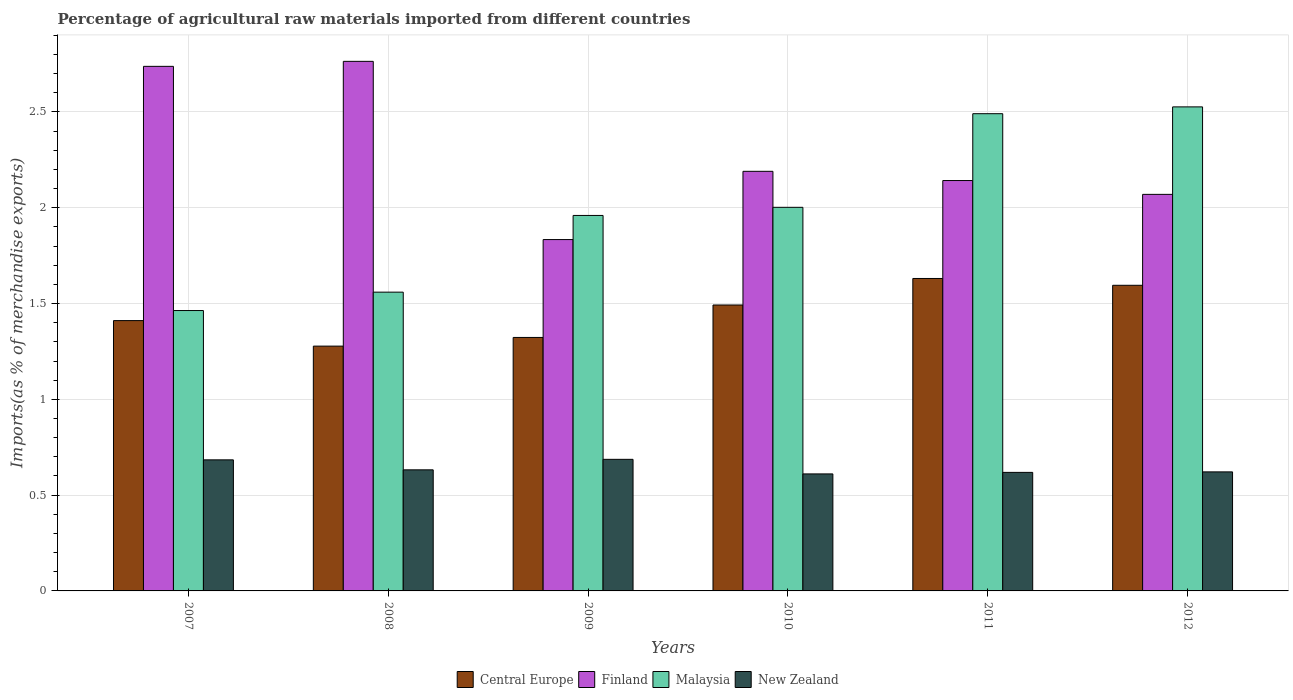How many different coloured bars are there?
Your answer should be very brief. 4. How many groups of bars are there?
Your answer should be very brief. 6. Are the number of bars on each tick of the X-axis equal?
Your response must be concise. Yes. How many bars are there on the 2nd tick from the left?
Provide a succinct answer. 4. How many bars are there on the 6th tick from the right?
Your answer should be very brief. 4. What is the percentage of imports to different countries in New Zealand in 2010?
Provide a succinct answer. 0.61. Across all years, what is the maximum percentage of imports to different countries in New Zealand?
Provide a succinct answer. 0.69. Across all years, what is the minimum percentage of imports to different countries in Central Europe?
Give a very brief answer. 1.28. What is the total percentage of imports to different countries in Finland in the graph?
Make the answer very short. 13.74. What is the difference between the percentage of imports to different countries in New Zealand in 2007 and that in 2008?
Give a very brief answer. 0.05. What is the difference between the percentage of imports to different countries in Finland in 2011 and the percentage of imports to different countries in Malaysia in 2007?
Provide a succinct answer. 0.68. What is the average percentage of imports to different countries in Central Europe per year?
Provide a succinct answer. 1.45. In the year 2012, what is the difference between the percentage of imports to different countries in Central Europe and percentage of imports to different countries in Finland?
Your answer should be compact. -0.47. In how many years, is the percentage of imports to different countries in Central Europe greater than 0.9 %?
Provide a succinct answer. 6. What is the ratio of the percentage of imports to different countries in Central Europe in 2011 to that in 2012?
Offer a terse response. 1.02. Is the difference between the percentage of imports to different countries in Central Europe in 2007 and 2009 greater than the difference between the percentage of imports to different countries in Finland in 2007 and 2009?
Ensure brevity in your answer.  No. What is the difference between the highest and the second highest percentage of imports to different countries in New Zealand?
Your response must be concise. 0. What is the difference between the highest and the lowest percentage of imports to different countries in Malaysia?
Your response must be concise. 1.06. What does the 3rd bar from the left in 2012 represents?
Offer a terse response. Malaysia. What does the 1st bar from the right in 2007 represents?
Ensure brevity in your answer.  New Zealand. Is it the case that in every year, the sum of the percentage of imports to different countries in Finland and percentage of imports to different countries in Malaysia is greater than the percentage of imports to different countries in New Zealand?
Give a very brief answer. Yes. How many bars are there?
Provide a succinct answer. 24. Are all the bars in the graph horizontal?
Ensure brevity in your answer.  No. How many years are there in the graph?
Offer a terse response. 6. Does the graph contain any zero values?
Your answer should be very brief. No. Does the graph contain grids?
Offer a very short reply. Yes. Where does the legend appear in the graph?
Give a very brief answer. Bottom center. What is the title of the graph?
Your answer should be very brief. Percentage of agricultural raw materials imported from different countries. What is the label or title of the X-axis?
Provide a succinct answer. Years. What is the label or title of the Y-axis?
Offer a very short reply. Imports(as % of merchandise exports). What is the Imports(as % of merchandise exports) of Central Europe in 2007?
Offer a terse response. 1.41. What is the Imports(as % of merchandise exports) in Finland in 2007?
Your response must be concise. 2.74. What is the Imports(as % of merchandise exports) in Malaysia in 2007?
Your answer should be compact. 1.46. What is the Imports(as % of merchandise exports) of New Zealand in 2007?
Ensure brevity in your answer.  0.68. What is the Imports(as % of merchandise exports) of Central Europe in 2008?
Give a very brief answer. 1.28. What is the Imports(as % of merchandise exports) of Finland in 2008?
Make the answer very short. 2.76. What is the Imports(as % of merchandise exports) in Malaysia in 2008?
Give a very brief answer. 1.56. What is the Imports(as % of merchandise exports) of New Zealand in 2008?
Your answer should be compact. 0.63. What is the Imports(as % of merchandise exports) of Central Europe in 2009?
Your response must be concise. 1.32. What is the Imports(as % of merchandise exports) of Finland in 2009?
Offer a very short reply. 1.83. What is the Imports(as % of merchandise exports) in Malaysia in 2009?
Keep it short and to the point. 1.96. What is the Imports(as % of merchandise exports) of New Zealand in 2009?
Keep it short and to the point. 0.69. What is the Imports(as % of merchandise exports) of Central Europe in 2010?
Your answer should be very brief. 1.49. What is the Imports(as % of merchandise exports) in Finland in 2010?
Make the answer very short. 2.19. What is the Imports(as % of merchandise exports) of Malaysia in 2010?
Give a very brief answer. 2. What is the Imports(as % of merchandise exports) in New Zealand in 2010?
Keep it short and to the point. 0.61. What is the Imports(as % of merchandise exports) in Central Europe in 2011?
Offer a terse response. 1.63. What is the Imports(as % of merchandise exports) in Finland in 2011?
Offer a terse response. 2.14. What is the Imports(as % of merchandise exports) of Malaysia in 2011?
Your response must be concise. 2.49. What is the Imports(as % of merchandise exports) in New Zealand in 2011?
Your answer should be very brief. 0.62. What is the Imports(as % of merchandise exports) in Central Europe in 2012?
Provide a short and direct response. 1.6. What is the Imports(as % of merchandise exports) in Finland in 2012?
Your answer should be compact. 2.07. What is the Imports(as % of merchandise exports) in Malaysia in 2012?
Your answer should be compact. 2.53. What is the Imports(as % of merchandise exports) of New Zealand in 2012?
Provide a succinct answer. 0.62. Across all years, what is the maximum Imports(as % of merchandise exports) of Central Europe?
Give a very brief answer. 1.63. Across all years, what is the maximum Imports(as % of merchandise exports) of Finland?
Your answer should be very brief. 2.76. Across all years, what is the maximum Imports(as % of merchandise exports) in Malaysia?
Give a very brief answer. 2.53. Across all years, what is the maximum Imports(as % of merchandise exports) of New Zealand?
Offer a very short reply. 0.69. Across all years, what is the minimum Imports(as % of merchandise exports) in Central Europe?
Your answer should be compact. 1.28. Across all years, what is the minimum Imports(as % of merchandise exports) in Finland?
Give a very brief answer. 1.83. Across all years, what is the minimum Imports(as % of merchandise exports) of Malaysia?
Provide a succinct answer. 1.46. Across all years, what is the minimum Imports(as % of merchandise exports) in New Zealand?
Offer a terse response. 0.61. What is the total Imports(as % of merchandise exports) in Central Europe in the graph?
Your answer should be very brief. 8.73. What is the total Imports(as % of merchandise exports) in Finland in the graph?
Your answer should be very brief. 13.74. What is the total Imports(as % of merchandise exports) in Malaysia in the graph?
Ensure brevity in your answer.  12. What is the total Imports(as % of merchandise exports) of New Zealand in the graph?
Make the answer very short. 3.85. What is the difference between the Imports(as % of merchandise exports) in Central Europe in 2007 and that in 2008?
Offer a very short reply. 0.13. What is the difference between the Imports(as % of merchandise exports) in Finland in 2007 and that in 2008?
Provide a succinct answer. -0.03. What is the difference between the Imports(as % of merchandise exports) of Malaysia in 2007 and that in 2008?
Give a very brief answer. -0.1. What is the difference between the Imports(as % of merchandise exports) of New Zealand in 2007 and that in 2008?
Provide a short and direct response. 0.05. What is the difference between the Imports(as % of merchandise exports) in Central Europe in 2007 and that in 2009?
Your response must be concise. 0.09. What is the difference between the Imports(as % of merchandise exports) in Finland in 2007 and that in 2009?
Ensure brevity in your answer.  0.9. What is the difference between the Imports(as % of merchandise exports) of Malaysia in 2007 and that in 2009?
Offer a terse response. -0.5. What is the difference between the Imports(as % of merchandise exports) in New Zealand in 2007 and that in 2009?
Your answer should be compact. -0. What is the difference between the Imports(as % of merchandise exports) in Central Europe in 2007 and that in 2010?
Ensure brevity in your answer.  -0.08. What is the difference between the Imports(as % of merchandise exports) of Finland in 2007 and that in 2010?
Provide a short and direct response. 0.55. What is the difference between the Imports(as % of merchandise exports) in Malaysia in 2007 and that in 2010?
Provide a succinct answer. -0.54. What is the difference between the Imports(as % of merchandise exports) in New Zealand in 2007 and that in 2010?
Keep it short and to the point. 0.07. What is the difference between the Imports(as % of merchandise exports) in Central Europe in 2007 and that in 2011?
Your answer should be compact. -0.22. What is the difference between the Imports(as % of merchandise exports) in Finland in 2007 and that in 2011?
Provide a succinct answer. 0.6. What is the difference between the Imports(as % of merchandise exports) in Malaysia in 2007 and that in 2011?
Your answer should be compact. -1.03. What is the difference between the Imports(as % of merchandise exports) of New Zealand in 2007 and that in 2011?
Provide a short and direct response. 0.07. What is the difference between the Imports(as % of merchandise exports) in Central Europe in 2007 and that in 2012?
Ensure brevity in your answer.  -0.18. What is the difference between the Imports(as % of merchandise exports) of Finland in 2007 and that in 2012?
Ensure brevity in your answer.  0.67. What is the difference between the Imports(as % of merchandise exports) of Malaysia in 2007 and that in 2012?
Give a very brief answer. -1.06. What is the difference between the Imports(as % of merchandise exports) in New Zealand in 2007 and that in 2012?
Your answer should be very brief. 0.06. What is the difference between the Imports(as % of merchandise exports) in Central Europe in 2008 and that in 2009?
Make the answer very short. -0.05. What is the difference between the Imports(as % of merchandise exports) in Finland in 2008 and that in 2009?
Make the answer very short. 0.93. What is the difference between the Imports(as % of merchandise exports) of Malaysia in 2008 and that in 2009?
Make the answer very short. -0.4. What is the difference between the Imports(as % of merchandise exports) of New Zealand in 2008 and that in 2009?
Make the answer very short. -0.05. What is the difference between the Imports(as % of merchandise exports) of Central Europe in 2008 and that in 2010?
Make the answer very short. -0.21. What is the difference between the Imports(as % of merchandise exports) in Finland in 2008 and that in 2010?
Offer a terse response. 0.57. What is the difference between the Imports(as % of merchandise exports) in Malaysia in 2008 and that in 2010?
Ensure brevity in your answer.  -0.44. What is the difference between the Imports(as % of merchandise exports) of New Zealand in 2008 and that in 2010?
Offer a terse response. 0.02. What is the difference between the Imports(as % of merchandise exports) of Central Europe in 2008 and that in 2011?
Your response must be concise. -0.35. What is the difference between the Imports(as % of merchandise exports) of Finland in 2008 and that in 2011?
Ensure brevity in your answer.  0.62. What is the difference between the Imports(as % of merchandise exports) in Malaysia in 2008 and that in 2011?
Your answer should be very brief. -0.93. What is the difference between the Imports(as % of merchandise exports) in New Zealand in 2008 and that in 2011?
Keep it short and to the point. 0.01. What is the difference between the Imports(as % of merchandise exports) in Central Europe in 2008 and that in 2012?
Offer a terse response. -0.32. What is the difference between the Imports(as % of merchandise exports) of Finland in 2008 and that in 2012?
Keep it short and to the point. 0.69. What is the difference between the Imports(as % of merchandise exports) of Malaysia in 2008 and that in 2012?
Keep it short and to the point. -0.97. What is the difference between the Imports(as % of merchandise exports) in New Zealand in 2008 and that in 2012?
Keep it short and to the point. 0.01. What is the difference between the Imports(as % of merchandise exports) in Central Europe in 2009 and that in 2010?
Keep it short and to the point. -0.17. What is the difference between the Imports(as % of merchandise exports) of Finland in 2009 and that in 2010?
Provide a succinct answer. -0.36. What is the difference between the Imports(as % of merchandise exports) in Malaysia in 2009 and that in 2010?
Make the answer very short. -0.04. What is the difference between the Imports(as % of merchandise exports) of New Zealand in 2009 and that in 2010?
Provide a succinct answer. 0.08. What is the difference between the Imports(as % of merchandise exports) of Central Europe in 2009 and that in 2011?
Your response must be concise. -0.31. What is the difference between the Imports(as % of merchandise exports) in Finland in 2009 and that in 2011?
Offer a terse response. -0.31. What is the difference between the Imports(as % of merchandise exports) in Malaysia in 2009 and that in 2011?
Give a very brief answer. -0.53. What is the difference between the Imports(as % of merchandise exports) in New Zealand in 2009 and that in 2011?
Provide a succinct answer. 0.07. What is the difference between the Imports(as % of merchandise exports) of Central Europe in 2009 and that in 2012?
Make the answer very short. -0.27. What is the difference between the Imports(as % of merchandise exports) of Finland in 2009 and that in 2012?
Offer a very short reply. -0.24. What is the difference between the Imports(as % of merchandise exports) of Malaysia in 2009 and that in 2012?
Ensure brevity in your answer.  -0.57. What is the difference between the Imports(as % of merchandise exports) in New Zealand in 2009 and that in 2012?
Provide a succinct answer. 0.07. What is the difference between the Imports(as % of merchandise exports) in Central Europe in 2010 and that in 2011?
Make the answer very short. -0.14. What is the difference between the Imports(as % of merchandise exports) of Finland in 2010 and that in 2011?
Ensure brevity in your answer.  0.05. What is the difference between the Imports(as % of merchandise exports) in Malaysia in 2010 and that in 2011?
Your response must be concise. -0.49. What is the difference between the Imports(as % of merchandise exports) of New Zealand in 2010 and that in 2011?
Offer a very short reply. -0.01. What is the difference between the Imports(as % of merchandise exports) in Central Europe in 2010 and that in 2012?
Provide a short and direct response. -0.1. What is the difference between the Imports(as % of merchandise exports) in Finland in 2010 and that in 2012?
Your response must be concise. 0.12. What is the difference between the Imports(as % of merchandise exports) in Malaysia in 2010 and that in 2012?
Your answer should be compact. -0.52. What is the difference between the Imports(as % of merchandise exports) of New Zealand in 2010 and that in 2012?
Your response must be concise. -0.01. What is the difference between the Imports(as % of merchandise exports) in Central Europe in 2011 and that in 2012?
Provide a short and direct response. 0.04. What is the difference between the Imports(as % of merchandise exports) of Finland in 2011 and that in 2012?
Keep it short and to the point. 0.07. What is the difference between the Imports(as % of merchandise exports) in Malaysia in 2011 and that in 2012?
Provide a succinct answer. -0.04. What is the difference between the Imports(as % of merchandise exports) of New Zealand in 2011 and that in 2012?
Give a very brief answer. -0. What is the difference between the Imports(as % of merchandise exports) in Central Europe in 2007 and the Imports(as % of merchandise exports) in Finland in 2008?
Provide a short and direct response. -1.35. What is the difference between the Imports(as % of merchandise exports) in Central Europe in 2007 and the Imports(as % of merchandise exports) in Malaysia in 2008?
Offer a very short reply. -0.15. What is the difference between the Imports(as % of merchandise exports) in Central Europe in 2007 and the Imports(as % of merchandise exports) in New Zealand in 2008?
Provide a short and direct response. 0.78. What is the difference between the Imports(as % of merchandise exports) of Finland in 2007 and the Imports(as % of merchandise exports) of Malaysia in 2008?
Your response must be concise. 1.18. What is the difference between the Imports(as % of merchandise exports) of Finland in 2007 and the Imports(as % of merchandise exports) of New Zealand in 2008?
Provide a succinct answer. 2.11. What is the difference between the Imports(as % of merchandise exports) in Malaysia in 2007 and the Imports(as % of merchandise exports) in New Zealand in 2008?
Your answer should be compact. 0.83. What is the difference between the Imports(as % of merchandise exports) in Central Europe in 2007 and the Imports(as % of merchandise exports) in Finland in 2009?
Keep it short and to the point. -0.42. What is the difference between the Imports(as % of merchandise exports) of Central Europe in 2007 and the Imports(as % of merchandise exports) of Malaysia in 2009?
Offer a terse response. -0.55. What is the difference between the Imports(as % of merchandise exports) in Central Europe in 2007 and the Imports(as % of merchandise exports) in New Zealand in 2009?
Provide a succinct answer. 0.72. What is the difference between the Imports(as % of merchandise exports) in Finland in 2007 and the Imports(as % of merchandise exports) in Malaysia in 2009?
Your response must be concise. 0.78. What is the difference between the Imports(as % of merchandise exports) of Finland in 2007 and the Imports(as % of merchandise exports) of New Zealand in 2009?
Your response must be concise. 2.05. What is the difference between the Imports(as % of merchandise exports) in Malaysia in 2007 and the Imports(as % of merchandise exports) in New Zealand in 2009?
Give a very brief answer. 0.78. What is the difference between the Imports(as % of merchandise exports) in Central Europe in 2007 and the Imports(as % of merchandise exports) in Finland in 2010?
Keep it short and to the point. -0.78. What is the difference between the Imports(as % of merchandise exports) in Central Europe in 2007 and the Imports(as % of merchandise exports) in Malaysia in 2010?
Your answer should be compact. -0.59. What is the difference between the Imports(as % of merchandise exports) of Central Europe in 2007 and the Imports(as % of merchandise exports) of New Zealand in 2010?
Offer a terse response. 0.8. What is the difference between the Imports(as % of merchandise exports) in Finland in 2007 and the Imports(as % of merchandise exports) in Malaysia in 2010?
Offer a very short reply. 0.74. What is the difference between the Imports(as % of merchandise exports) in Finland in 2007 and the Imports(as % of merchandise exports) in New Zealand in 2010?
Your answer should be very brief. 2.13. What is the difference between the Imports(as % of merchandise exports) in Malaysia in 2007 and the Imports(as % of merchandise exports) in New Zealand in 2010?
Keep it short and to the point. 0.85. What is the difference between the Imports(as % of merchandise exports) of Central Europe in 2007 and the Imports(as % of merchandise exports) of Finland in 2011?
Give a very brief answer. -0.73. What is the difference between the Imports(as % of merchandise exports) in Central Europe in 2007 and the Imports(as % of merchandise exports) in Malaysia in 2011?
Give a very brief answer. -1.08. What is the difference between the Imports(as % of merchandise exports) of Central Europe in 2007 and the Imports(as % of merchandise exports) of New Zealand in 2011?
Your answer should be compact. 0.79. What is the difference between the Imports(as % of merchandise exports) in Finland in 2007 and the Imports(as % of merchandise exports) in Malaysia in 2011?
Your response must be concise. 0.25. What is the difference between the Imports(as % of merchandise exports) of Finland in 2007 and the Imports(as % of merchandise exports) of New Zealand in 2011?
Your response must be concise. 2.12. What is the difference between the Imports(as % of merchandise exports) of Malaysia in 2007 and the Imports(as % of merchandise exports) of New Zealand in 2011?
Your answer should be very brief. 0.84. What is the difference between the Imports(as % of merchandise exports) of Central Europe in 2007 and the Imports(as % of merchandise exports) of Finland in 2012?
Offer a terse response. -0.66. What is the difference between the Imports(as % of merchandise exports) in Central Europe in 2007 and the Imports(as % of merchandise exports) in Malaysia in 2012?
Your answer should be compact. -1.12. What is the difference between the Imports(as % of merchandise exports) of Central Europe in 2007 and the Imports(as % of merchandise exports) of New Zealand in 2012?
Your response must be concise. 0.79. What is the difference between the Imports(as % of merchandise exports) in Finland in 2007 and the Imports(as % of merchandise exports) in Malaysia in 2012?
Give a very brief answer. 0.21. What is the difference between the Imports(as % of merchandise exports) of Finland in 2007 and the Imports(as % of merchandise exports) of New Zealand in 2012?
Keep it short and to the point. 2.12. What is the difference between the Imports(as % of merchandise exports) in Malaysia in 2007 and the Imports(as % of merchandise exports) in New Zealand in 2012?
Offer a terse response. 0.84. What is the difference between the Imports(as % of merchandise exports) in Central Europe in 2008 and the Imports(as % of merchandise exports) in Finland in 2009?
Your answer should be very brief. -0.56. What is the difference between the Imports(as % of merchandise exports) of Central Europe in 2008 and the Imports(as % of merchandise exports) of Malaysia in 2009?
Keep it short and to the point. -0.68. What is the difference between the Imports(as % of merchandise exports) in Central Europe in 2008 and the Imports(as % of merchandise exports) in New Zealand in 2009?
Provide a succinct answer. 0.59. What is the difference between the Imports(as % of merchandise exports) in Finland in 2008 and the Imports(as % of merchandise exports) in Malaysia in 2009?
Keep it short and to the point. 0.8. What is the difference between the Imports(as % of merchandise exports) of Finland in 2008 and the Imports(as % of merchandise exports) of New Zealand in 2009?
Offer a terse response. 2.08. What is the difference between the Imports(as % of merchandise exports) in Malaysia in 2008 and the Imports(as % of merchandise exports) in New Zealand in 2009?
Give a very brief answer. 0.87. What is the difference between the Imports(as % of merchandise exports) in Central Europe in 2008 and the Imports(as % of merchandise exports) in Finland in 2010?
Ensure brevity in your answer.  -0.91. What is the difference between the Imports(as % of merchandise exports) in Central Europe in 2008 and the Imports(as % of merchandise exports) in Malaysia in 2010?
Your answer should be very brief. -0.72. What is the difference between the Imports(as % of merchandise exports) in Central Europe in 2008 and the Imports(as % of merchandise exports) in New Zealand in 2010?
Offer a terse response. 0.67. What is the difference between the Imports(as % of merchandise exports) of Finland in 2008 and the Imports(as % of merchandise exports) of Malaysia in 2010?
Your answer should be compact. 0.76. What is the difference between the Imports(as % of merchandise exports) in Finland in 2008 and the Imports(as % of merchandise exports) in New Zealand in 2010?
Offer a very short reply. 2.15. What is the difference between the Imports(as % of merchandise exports) of Malaysia in 2008 and the Imports(as % of merchandise exports) of New Zealand in 2010?
Ensure brevity in your answer.  0.95. What is the difference between the Imports(as % of merchandise exports) in Central Europe in 2008 and the Imports(as % of merchandise exports) in Finland in 2011?
Offer a very short reply. -0.86. What is the difference between the Imports(as % of merchandise exports) of Central Europe in 2008 and the Imports(as % of merchandise exports) of Malaysia in 2011?
Offer a terse response. -1.21. What is the difference between the Imports(as % of merchandise exports) in Central Europe in 2008 and the Imports(as % of merchandise exports) in New Zealand in 2011?
Ensure brevity in your answer.  0.66. What is the difference between the Imports(as % of merchandise exports) of Finland in 2008 and the Imports(as % of merchandise exports) of Malaysia in 2011?
Give a very brief answer. 0.27. What is the difference between the Imports(as % of merchandise exports) of Finland in 2008 and the Imports(as % of merchandise exports) of New Zealand in 2011?
Keep it short and to the point. 2.15. What is the difference between the Imports(as % of merchandise exports) in Malaysia in 2008 and the Imports(as % of merchandise exports) in New Zealand in 2011?
Your answer should be compact. 0.94. What is the difference between the Imports(as % of merchandise exports) in Central Europe in 2008 and the Imports(as % of merchandise exports) in Finland in 2012?
Provide a succinct answer. -0.79. What is the difference between the Imports(as % of merchandise exports) in Central Europe in 2008 and the Imports(as % of merchandise exports) in Malaysia in 2012?
Keep it short and to the point. -1.25. What is the difference between the Imports(as % of merchandise exports) of Central Europe in 2008 and the Imports(as % of merchandise exports) of New Zealand in 2012?
Keep it short and to the point. 0.66. What is the difference between the Imports(as % of merchandise exports) in Finland in 2008 and the Imports(as % of merchandise exports) in Malaysia in 2012?
Offer a terse response. 0.24. What is the difference between the Imports(as % of merchandise exports) in Finland in 2008 and the Imports(as % of merchandise exports) in New Zealand in 2012?
Keep it short and to the point. 2.14. What is the difference between the Imports(as % of merchandise exports) in Malaysia in 2008 and the Imports(as % of merchandise exports) in New Zealand in 2012?
Your answer should be compact. 0.94. What is the difference between the Imports(as % of merchandise exports) in Central Europe in 2009 and the Imports(as % of merchandise exports) in Finland in 2010?
Ensure brevity in your answer.  -0.87. What is the difference between the Imports(as % of merchandise exports) in Central Europe in 2009 and the Imports(as % of merchandise exports) in Malaysia in 2010?
Your answer should be very brief. -0.68. What is the difference between the Imports(as % of merchandise exports) of Central Europe in 2009 and the Imports(as % of merchandise exports) of New Zealand in 2010?
Your answer should be compact. 0.71. What is the difference between the Imports(as % of merchandise exports) in Finland in 2009 and the Imports(as % of merchandise exports) in Malaysia in 2010?
Make the answer very short. -0.17. What is the difference between the Imports(as % of merchandise exports) of Finland in 2009 and the Imports(as % of merchandise exports) of New Zealand in 2010?
Ensure brevity in your answer.  1.22. What is the difference between the Imports(as % of merchandise exports) of Malaysia in 2009 and the Imports(as % of merchandise exports) of New Zealand in 2010?
Ensure brevity in your answer.  1.35. What is the difference between the Imports(as % of merchandise exports) of Central Europe in 2009 and the Imports(as % of merchandise exports) of Finland in 2011?
Offer a terse response. -0.82. What is the difference between the Imports(as % of merchandise exports) in Central Europe in 2009 and the Imports(as % of merchandise exports) in Malaysia in 2011?
Make the answer very short. -1.17. What is the difference between the Imports(as % of merchandise exports) in Central Europe in 2009 and the Imports(as % of merchandise exports) in New Zealand in 2011?
Keep it short and to the point. 0.7. What is the difference between the Imports(as % of merchandise exports) of Finland in 2009 and the Imports(as % of merchandise exports) of Malaysia in 2011?
Provide a succinct answer. -0.66. What is the difference between the Imports(as % of merchandise exports) of Finland in 2009 and the Imports(as % of merchandise exports) of New Zealand in 2011?
Your response must be concise. 1.22. What is the difference between the Imports(as % of merchandise exports) of Malaysia in 2009 and the Imports(as % of merchandise exports) of New Zealand in 2011?
Your response must be concise. 1.34. What is the difference between the Imports(as % of merchandise exports) in Central Europe in 2009 and the Imports(as % of merchandise exports) in Finland in 2012?
Offer a terse response. -0.75. What is the difference between the Imports(as % of merchandise exports) in Central Europe in 2009 and the Imports(as % of merchandise exports) in Malaysia in 2012?
Your answer should be very brief. -1.2. What is the difference between the Imports(as % of merchandise exports) in Central Europe in 2009 and the Imports(as % of merchandise exports) in New Zealand in 2012?
Offer a very short reply. 0.7. What is the difference between the Imports(as % of merchandise exports) of Finland in 2009 and the Imports(as % of merchandise exports) of Malaysia in 2012?
Your response must be concise. -0.69. What is the difference between the Imports(as % of merchandise exports) in Finland in 2009 and the Imports(as % of merchandise exports) in New Zealand in 2012?
Your response must be concise. 1.21. What is the difference between the Imports(as % of merchandise exports) of Malaysia in 2009 and the Imports(as % of merchandise exports) of New Zealand in 2012?
Provide a succinct answer. 1.34. What is the difference between the Imports(as % of merchandise exports) in Central Europe in 2010 and the Imports(as % of merchandise exports) in Finland in 2011?
Your answer should be compact. -0.65. What is the difference between the Imports(as % of merchandise exports) in Central Europe in 2010 and the Imports(as % of merchandise exports) in Malaysia in 2011?
Your answer should be compact. -1. What is the difference between the Imports(as % of merchandise exports) in Central Europe in 2010 and the Imports(as % of merchandise exports) in New Zealand in 2011?
Keep it short and to the point. 0.87. What is the difference between the Imports(as % of merchandise exports) in Finland in 2010 and the Imports(as % of merchandise exports) in Malaysia in 2011?
Your response must be concise. -0.3. What is the difference between the Imports(as % of merchandise exports) in Finland in 2010 and the Imports(as % of merchandise exports) in New Zealand in 2011?
Ensure brevity in your answer.  1.57. What is the difference between the Imports(as % of merchandise exports) in Malaysia in 2010 and the Imports(as % of merchandise exports) in New Zealand in 2011?
Keep it short and to the point. 1.38. What is the difference between the Imports(as % of merchandise exports) of Central Europe in 2010 and the Imports(as % of merchandise exports) of Finland in 2012?
Provide a short and direct response. -0.58. What is the difference between the Imports(as % of merchandise exports) of Central Europe in 2010 and the Imports(as % of merchandise exports) of Malaysia in 2012?
Your answer should be very brief. -1.03. What is the difference between the Imports(as % of merchandise exports) in Central Europe in 2010 and the Imports(as % of merchandise exports) in New Zealand in 2012?
Keep it short and to the point. 0.87. What is the difference between the Imports(as % of merchandise exports) in Finland in 2010 and the Imports(as % of merchandise exports) in Malaysia in 2012?
Keep it short and to the point. -0.34. What is the difference between the Imports(as % of merchandise exports) in Finland in 2010 and the Imports(as % of merchandise exports) in New Zealand in 2012?
Keep it short and to the point. 1.57. What is the difference between the Imports(as % of merchandise exports) of Malaysia in 2010 and the Imports(as % of merchandise exports) of New Zealand in 2012?
Make the answer very short. 1.38. What is the difference between the Imports(as % of merchandise exports) in Central Europe in 2011 and the Imports(as % of merchandise exports) in Finland in 2012?
Ensure brevity in your answer.  -0.44. What is the difference between the Imports(as % of merchandise exports) in Central Europe in 2011 and the Imports(as % of merchandise exports) in Malaysia in 2012?
Make the answer very short. -0.9. What is the difference between the Imports(as % of merchandise exports) in Central Europe in 2011 and the Imports(as % of merchandise exports) in New Zealand in 2012?
Provide a short and direct response. 1.01. What is the difference between the Imports(as % of merchandise exports) in Finland in 2011 and the Imports(as % of merchandise exports) in Malaysia in 2012?
Your answer should be very brief. -0.38. What is the difference between the Imports(as % of merchandise exports) of Finland in 2011 and the Imports(as % of merchandise exports) of New Zealand in 2012?
Offer a very short reply. 1.52. What is the difference between the Imports(as % of merchandise exports) of Malaysia in 2011 and the Imports(as % of merchandise exports) of New Zealand in 2012?
Ensure brevity in your answer.  1.87. What is the average Imports(as % of merchandise exports) of Central Europe per year?
Your answer should be very brief. 1.45. What is the average Imports(as % of merchandise exports) in Finland per year?
Ensure brevity in your answer.  2.29. What is the average Imports(as % of merchandise exports) in Malaysia per year?
Keep it short and to the point. 2. What is the average Imports(as % of merchandise exports) of New Zealand per year?
Offer a very short reply. 0.64. In the year 2007, what is the difference between the Imports(as % of merchandise exports) of Central Europe and Imports(as % of merchandise exports) of Finland?
Offer a very short reply. -1.33. In the year 2007, what is the difference between the Imports(as % of merchandise exports) of Central Europe and Imports(as % of merchandise exports) of Malaysia?
Provide a succinct answer. -0.05. In the year 2007, what is the difference between the Imports(as % of merchandise exports) of Central Europe and Imports(as % of merchandise exports) of New Zealand?
Your response must be concise. 0.73. In the year 2007, what is the difference between the Imports(as % of merchandise exports) in Finland and Imports(as % of merchandise exports) in Malaysia?
Your response must be concise. 1.27. In the year 2007, what is the difference between the Imports(as % of merchandise exports) of Finland and Imports(as % of merchandise exports) of New Zealand?
Ensure brevity in your answer.  2.05. In the year 2007, what is the difference between the Imports(as % of merchandise exports) in Malaysia and Imports(as % of merchandise exports) in New Zealand?
Your response must be concise. 0.78. In the year 2008, what is the difference between the Imports(as % of merchandise exports) of Central Europe and Imports(as % of merchandise exports) of Finland?
Keep it short and to the point. -1.49. In the year 2008, what is the difference between the Imports(as % of merchandise exports) of Central Europe and Imports(as % of merchandise exports) of Malaysia?
Your answer should be very brief. -0.28. In the year 2008, what is the difference between the Imports(as % of merchandise exports) in Central Europe and Imports(as % of merchandise exports) in New Zealand?
Give a very brief answer. 0.65. In the year 2008, what is the difference between the Imports(as % of merchandise exports) of Finland and Imports(as % of merchandise exports) of Malaysia?
Offer a very short reply. 1.2. In the year 2008, what is the difference between the Imports(as % of merchandise exports) of Finland and Imports(as % of merchandise exports) of New Zealand?
Provide a succinct answer. 2.13. In the year 2008, what is the difference between the Imports(as % of merchandise exports) in Malaysia and Imports(as % of merchandise exports) in New Zealand?
Give a very brief answer. 0.93. In the year 2009, what is the difference between the Imports(as % of merchandise exports) of Central Europe and Imports(as % of merchandise exports) of Finland?
Offer a terse response. -0.51. In the year 2009, what is the difference between the Imports(as % of merchandise exports) in Central Europe and Imports(as % of merchandise exports) in Malaysia?
Your response must be concise. -0.64. In the year 2009, what is the difference between the Imports(as % of merchandise exports) of Central Europe and Imports(as % of merchandise exports) of New Zealand?
Ensure brevity in your answer.  0.64. In the year 2009, what is the difference between the Imports(as % of merchandise exports) in Finland and Imports(as % of merchandise exports) in Malaysia?
Offer a terse response. -0.13. In the year 2009, what is the difference between the Imports(as % of merchandise exports) of Finland and Imports(as % of merchandise exports) of New Zealand?
Offer a terse response. 1.15. In the year 2009, what is the difference between the Imports(as % of merchandise exports) of Malaysia and Imports(as % of merchandise exports) of New Zealand?
Your response must be concise. 1.27. In the year 2010, what is the difference between the Imports(as % of merchandise exports) in Central Europe and Imports(as % of merchandise exports) in Finland?
Your response must be concise. -0.7. In the year 2010, what is the difference between the Imports(as % of merchandise exports) in Central Europe and Imports(as % of merchandise exports) in Malaysia?
Ensure brevity in your answer.  -0.51. In the year 2010, what is the difference between the Imports(as % of merchandise exports) in Central Europe and Imports(as % of merchandise exports) in New Zealand?
Make the answer very short. 0.88. In the year 2010, what is the difference between the Imports(as % of merchandise exports) of Finland and Imports(as % of merchandise exports) of Malaysia?
Keep it short and to the point. 0.19. In the year 2010, what is the difference between the Imports(as % of merchandise exports) of Finland and Imports(as % of merchandise exports) of New Zealand?
Offer a terse response. 1.58. In the year 2010, what is the difference between the Imports(as % of merchandise exports) of Malaysia and Imports(as % of merchandise exports) of New Zealand?
Your response must be concise. 1.39. In the year 2011, what is the difference between the Imports(as % of merchandise exports) of Central Europe and Imports(as % of merchandise exports) of Finland?
Make the answer very short. -0.51. In the year 2011, what is the difference between the Imports(as % of merchandise exports) of Central Europe and Imports(as % of merchandise exports) of Malaysia?
Provide a succinct answer. -0.86. In the year 2011, what is the difference between the Imports(as % of merchandise exports) of Finland and Imports(as % of merchandise exports) of Malaysia?
Offer a very short reply. -0.35. In the year 2011, what is the difference between the Imports(as % of merchandise exports) of Finland and Imports(as % of merchandise exports) of New Zealand?
Your response must be concise. 1.52. In the year 2011, what is the difference between the Imports(as % of merchandise exports) in Malaysia and Imports(as % of merchandise exports) in New Zealand?
Make the answer very short. 1.87. In the year 2012, what is the difference between the Imports(as % of merchandise exports) in Central Europe and Imports(as % of merchandise exports) in Finland?
Your answer should be compact. -0.47. In the year 2012, what is the difference between the Imports(as % of merchandise exports) in Central Europe and Imports(as % of merchandise exports) in Malaysia?
Make the answer very short. -0.93. In the year 2012, what is the difference between the Imports(as % of merchandise exports) in Central Europe and Imports(as % of merchandise exports) in New Zealand?
Give a very brief answer. 0.97. In the year 2012, what is the difference between the Imports(as % of merchandise exports) in Finland and Imports(as % of merchandise exports) in Malaysia?
Make the answer very short. -0.46. In the year 2012, what is the difference between the Imports(as % of merchandise exports) of Finland and Imports(as % of merchandise exports) of New Zealand?
Your answer should be very brief. 1.45. In the year 2012, what is the difference between the Imports(as % of merchandise exports) of Malaysia and Imports(as % of merchandise exports) of New Zealand?
Your answer should be compact. 1.91. What is the ratio of the Imports(as % of merchandise exports) of Central Europe in 2007 to that in 2008?
Provide a succinct answer. 1.1. What is the ratio of the Imports(as % of merchandise exports) of Finland in 2007 to that in 2008?
Your answer should be compact. 0.99. What is the ratio of the Imports(as % of merchandise exports) of Malaysia in 2007 to that in 2008?
Keep it short and to the point. 0.94. What is the ratio of the Imports(as % of merchandise exports) in New Zealand in 2007 to that in 2008?
Provide a short and direct response. 1.08. What is the ratio of the Imports(as % of merchandise exports) of Central Europe in 2007 to that in 2009?
Offer a terse response. 1.07. What is the ratio of the Imports(as % of merchandise exports) in Finland in 2007 to that in 2009?
Your answer should be compact. 1.49. What is the ratio of the Imports(as % of merchandise exports) in Malaysia in 2007 to that in 2009?
Make the answer very short. 0.75. What is the ratio of the Imports(as % of merchandise exports) of New Zealand in 2007 to that in 2009?
Provide a short and direct response. 1. What is the ratio of the Imports(as % of merchandise exports) in Central Europe in 2007 to that in 2010?
Provide a short and direct response. 0.95. What is the ratio of the Imports(as % of merchandise exports) of Finland in 2007 to that in 2010?
Your response must be concise. 1.25. What is the ratio of the Imports(as % of merchandise exports) of Malaysia in 2007 to that in 2010?
Ensure brevity in your answer.  0.73. What is the ratio of the Imports(as % of merchandise exports) of New Zealand in 2007 to that in 2010?
Your response must be concise. 1.12. What is the ratio of the Imports(as % of merchandise exports) in Central Europe in 2007 to that in 2011?
Provide a succinct answer. 0.87. What is the ratio of the Imports(as % of merchandise exports) of Finland in 2007 to that in 2011?
Ensure brevity in your answer.  1.28. What is the ratio of the Imports(as % of merchandise exports) of Malaysia in 2007 to that in 2011?
Offer a terse response. 0.59. What is the ratio of the Imports(as % of merchandise exports) in New Zealand in 2007 to that in 2011?
Give a very brief answer. 1.11. What is the ratio of the Imports(as % of merchandise exports) of Central Europe in 2007 to that in 2012?
Your response must be concise. 0.88. What is the ratio of the Imports(as % of merchandise exports) in Finland in 2007 to that in 2012?
Offer a terse response. 1.32. What is the ratio of the Imports(as % of merchandise exports) in Malaysia in 2007 to that in 2012?
Your response must be concise. 0.58. What is the ratio of the Imports(as % of merchandise exports) in New Zealand in 2007 to that in 2012?
Ensure brevity in your answer.  1.1. What is the ratio of the Imports(as % of merchandise exports) of Central Europe in 2008 to that in 2009?
Make the answer very short. 0.97. What is the ratio of the Imports(as % of merchandise exports) in Finland in 2008 to that in 2009?
Your response must be concise. 1.51. What is the ratio of the Imports(as % of merchandise exports) of Malaysia in 2008 to that in 2009?
Your response must be concise. 0.8. What is the ratio of the Imports(as % of merchandise exports) of New Zealand in 2008 to that in 2009?
Give a very brief answer. 0.92. What is the ratio of the Imports(as % of merchandise exports) in Central Europe in 2008 to that in 2010?
Your answer should be compact. 0.86. What is the ratio of the Imports(as % of merchandise exports) in Finland in 2008 to that in 2010?
Your answer should be very brief. 1.26. What is the ratio of the Imports(as % of merchandise exports) in Malaysia in 2008 to that in 2010?
Provide a succinct answer. 0.78. What is the ratio of the Imports(as % of merchandise exports) in New Zealand in 2008 to that in 2010?
Your answer should be very brief. 1.03. What is the ratio of the Imports(as % of merchandise exports) of Central Europe in 2008 to that in 2011?
Offer a terse response. 0.78. What is the ratio of the Imports(as % of merchandise exports) of Finland in 2008 to that in 2011?
Offer a terse response. 1.29. What is the ratio of the Imports(as % of merchandise exports) of Malaysia in 2008 to that in 2011?
Your answer should be compact. 0.63. What is the ratio of the Imports(as % of merchandise exports) in New Zealand in 2008 to that in 2011?
Keep it short and to the point. 1.02. What is the ratio of the Imports(as % of merchandise exports) in Central Europe in 2008 to that in 2012?
Your response must be concise. 0.8. What is the ratio of the Imports(as % of merchandise exports) of Finland in 2008 to that in 2012?
Make the answer very short. 1.34. What is the ratio of the Imports(as % of merchandise exports) in Malaysia in 2008 to that in 2012?
Your response must be concise. 0.62. What is the ratio of the Imports(as % of merchandise exports) of New Zealand in 2008 to that in 2012?
Offer a very short reply. 1.02. What is the ratio of the Imports(as % of merchandise exports) of Central Europe in 2009 to that in 2010?
Your response must be concise. 0.89. What is the ratio of the Imports(as % of merchandise exports) of Finland in 2009 to that in 2010?
Give a very brief answer. 0.84. What is the ratio of the Imports(as % of merchandise exports) in Malaysia in 2009 to that in 2010?
Ensure brevity in your answer.  0.98. What is the ratio of the Imports(as % of merchandise exports) in New Zealand in 2009 to that in 2010?
Your response must be concise. 1.12. What is the ratio of the Imports(as % of merchandise exports) of Central Europe in 2009 to that in 2011?
Your answer should be very brief. 0.81. What is the ratio of the Imports(as % of merchandise exports) in Finland in 2009 to that in 2011?
Provide a short and direct response. 0.86. What is the ratio of the Imports(as % of merchandise exports) in Malaysia in 2009 to that in 2011?
Keep it short and to the point. 0.79. What is the ratio of the Imports(as % of merchandise exports) in New Zealand in 2009 to that in 2011?
Offer a very short reply. 1.11. What is the ratio of the Imports(as % of merchandise exports) in Central Europe in 2009 to that in 2012?
Provide a short and direct response. 0.83. What is the ratio of the Imports(as % of merchandise exports) of Finland in 2009 to that in 2012?
Offer a terse response. 0.89. What is the ratio of the Imports(as % of merchandise exports) in Malaysia in 2009 to that in 2012?
Make the answer very short. 0.78. What is the ratio of the Imports(as % of merchandise exports) of New Zealand in 2009 to that in 2012?
Your response must be concise. 1.11. What is the ratio of the Imports(as % of merchandise exports) in Central Europe in 2010 to that in 2011?
Your answer should be very brief. 0.92. What is the ratio of the Imports(as % of merchandise exports) of Finland in 2010 to that in 2011?
Your response must be concise. 1.02. What is the ratio of the Imports(as % of merchandise exports) of Malaysia in 2010 to that in 2011?
Offer a very short reply. 0.8. What is the ratio of the Imports(as % of merchandise exports) in Central Europe in 2010 to that in 2012?
Provide a short and direct response. 0.94. What is the ratio of the Imports(as % of merchandise exports) in Finland in 2010 to that in 2012?
Offer a terse response. 1.06. What is the ratio of the Imports(as % of merchandise exports) of Malaysia in 2010 to that in 2012?
Give a very brief answer. 0.79. What is the ratio of the Imports(as % of merchandise exports) of New Zealand in 2010 to that in 2012?
Provide a short and direct response. 0.98. What is the ratio of the Imports(as % of merchandise exports) of Central Europe in 2011 to that in 2012?
Offer a very short reply. 1.02. What is the ratio of the Imports(as % of merchandise exports) of Finland in 2011 to that in 2012?
Your answer should be compact. 1.03. What is the ratio of the Imports(as % of merchandise exports) in Malaysia in 2011 to that in 2012?
Provide a succinct answer. 0.99. What is the difference between the highest and the second highest Imports(as % of merchandise exports) in Central Europe?
Provide a succinct answer. 0.04. What is the difference between the highest and the second highest Imports(as % of merchandise exports) of Finland?
Offer a very short reply. 0.03. What is the difference between the highest and the second highest Imports(as % of merchandise exports) in Malaysia?
Provide a succinct answer. 0.04. What is the difference between the highest and the second highest Imports(as % of merchandise exports) in New Zealand?
Your response must be concise. 0. What is the difference between the highest and the lowest Imports(as % of merchandise exports) of Central Europe?
Give a very brief answer. 0.35. What is the difference between the highest and the lowest Imports(as % of merchandise exports) of Finland?
Offer a very short reply. 0.93. What is the difference between the highest and the lowest Imports(as % of merchandise exports) in Malaysia?
Your response must be concise. 1.06. What is the difference between the highest and the lowest Imports(as % of merchandise exports) in New Zealand?
Provide a short and direct response. 0.08. 